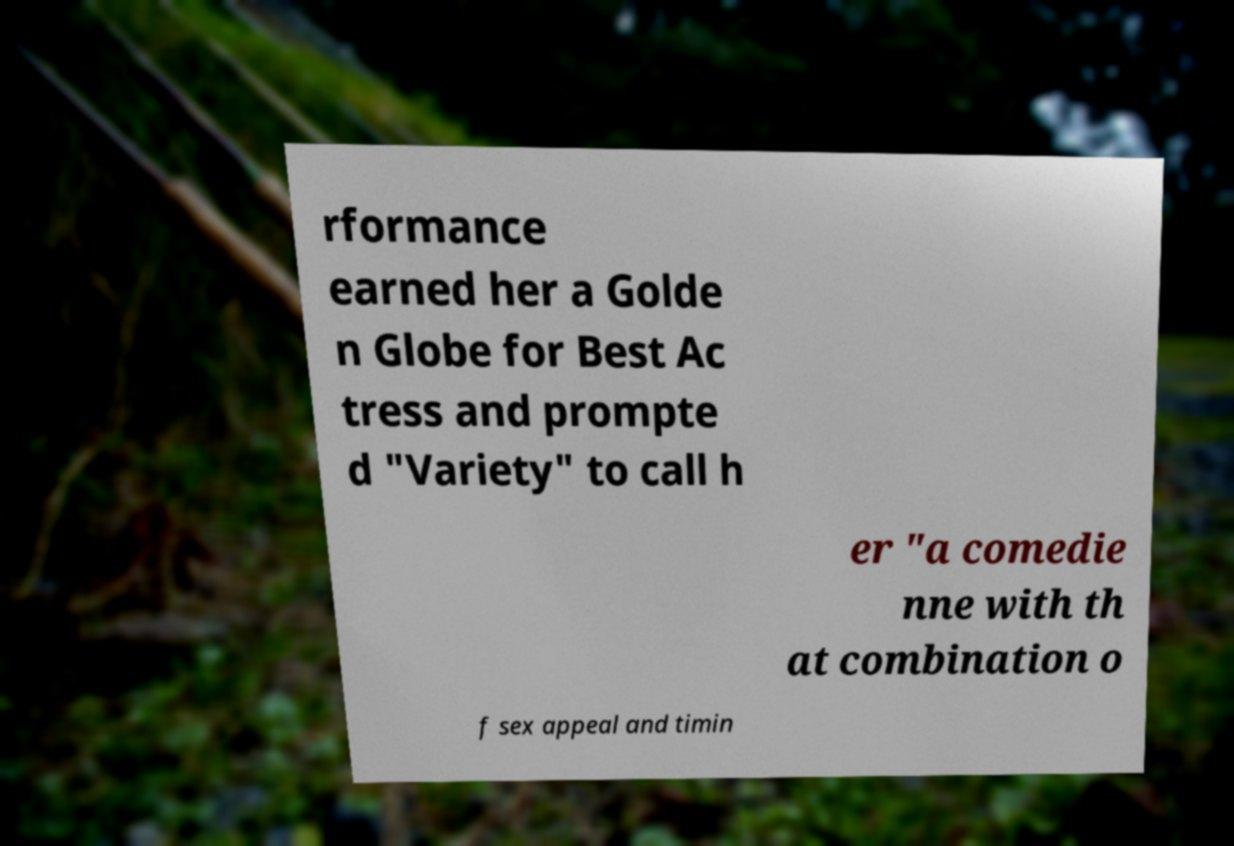What messages or text are displayed in this image? I need them in a readable, typed format. rformance earned her a Golde n Globe for Best Ac tress and prompte d "Variety" to call h er "a comedie nne with th at combination o f sex appeal and timin 